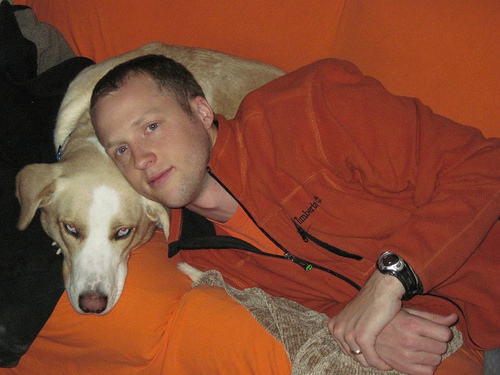<image>
Is there a man head on the dog? Yes. Looking at the image, I can see the man head is positioned on top of the dog, with the dog providing support. 